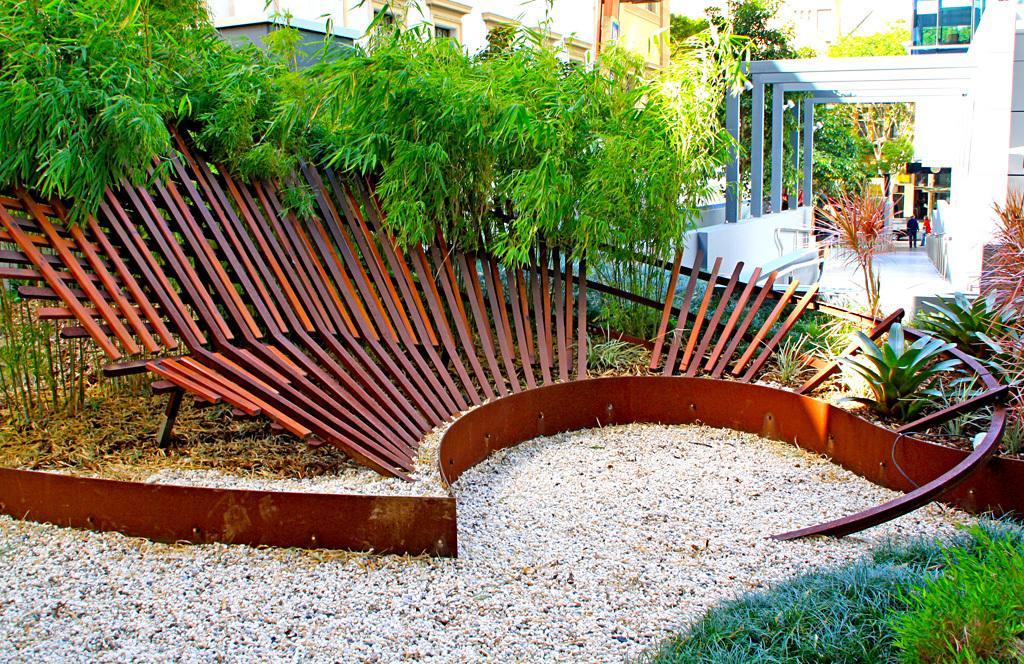Can you describe this image briefly? In this picture there is a brown color metal frame on the ground. Behind there are some green plants. Behind there is a metal frame and lobby and in the background we can see the yellow color building. 